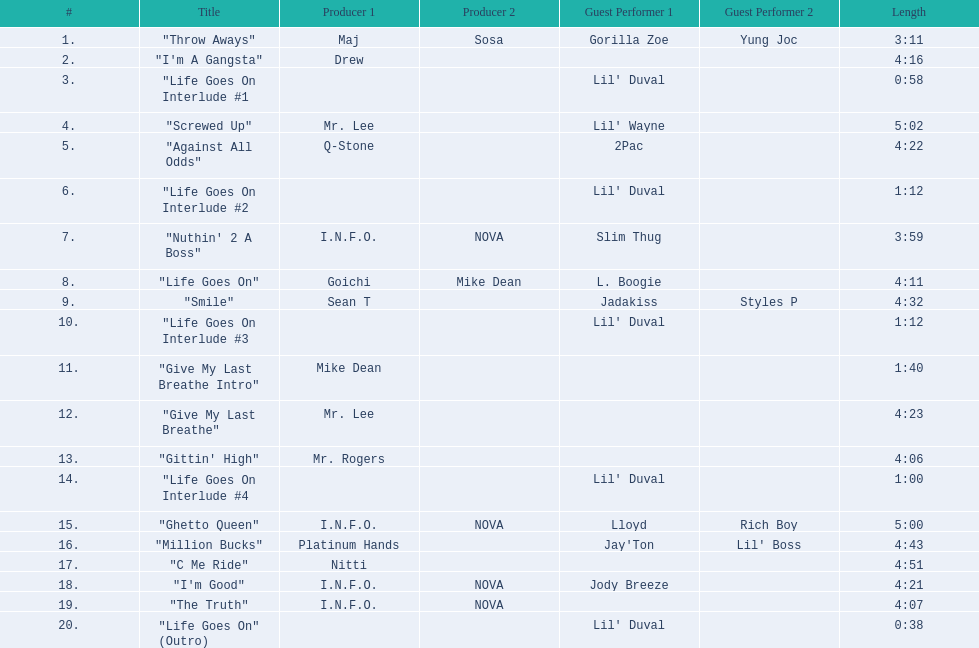How long is track number 11? 1:40. 